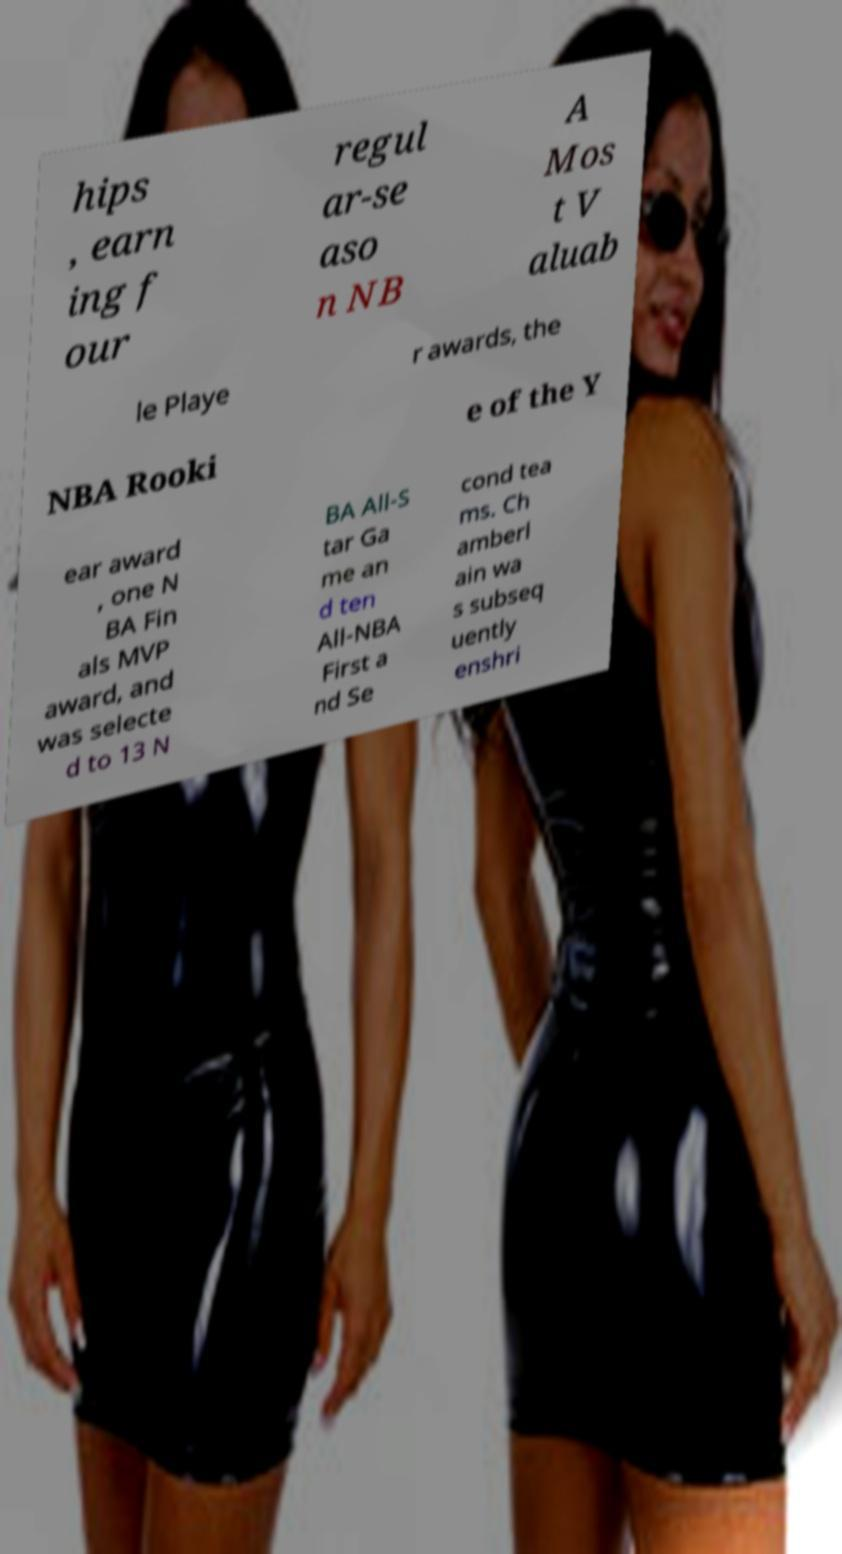Could you assist in decoding the text presented in this image and type it out clearly? hips , earn ing f our regul ar-se aso n NB A Mos t V aluab le Playe r awards, the NBA Rooki e of the Y ear award , one N BA Fin als MVP award, and was selecte d to 13 N BA All-S tar Ga me an d ten All-NBA First a nd Se cond tea ms. Ch amberl ain wa s subseq uently enshri 